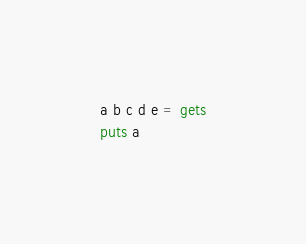Convert code to text. <code><loc_0><loc_0><loc_500><loc_500><_Ruby_>a b c d e = gets
puts a</code> 